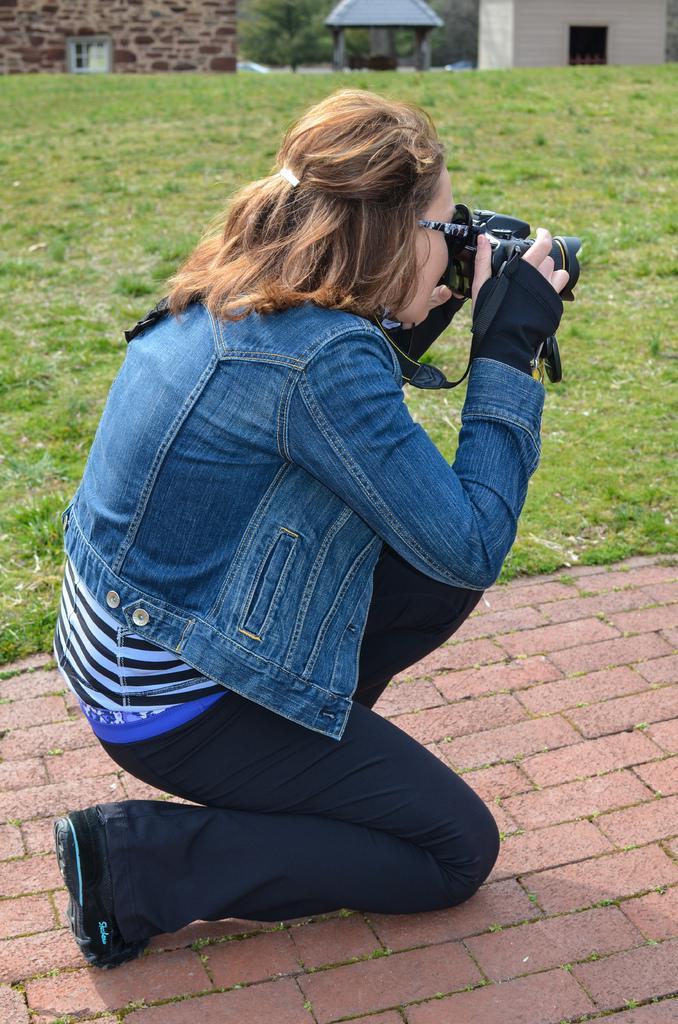Please provide a concise description of this image. In this image there is a woman holding a camera in her hand. She is on the path. Behind her there is grassland. Top of the image there are few buildings. Behind there is a tree. 